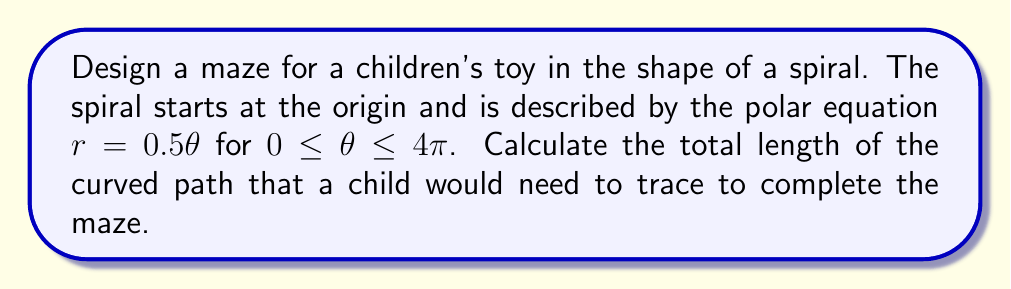Give your solution to this math problem. To find the length of the curved path in polar form, we need to use the arc length formula for polar curves:

$$L = \int_a^b \sqrt{r^2 + \left(\frac{dr}{d\theta}\right)^2} d\theta$$

Where $r$ is the radius, and $\theta$ is the angle in radians.

Step 1: Identify the given information
- Polar equation: $r = 0.5\theta$
- Limits: $0 \leq \theta \leq 4\pi$

Step 2: Find $\frac{dr}{d\theta}$
$$\frac{dr}{d\theta} = 0.5$$

Step 3: Substitute into the arc length formula
$$L = \int_0^{4\pi} \sqrt{(0.5\theta)^2 + (0.5)^2} d\theta$$

Step 4: Simplify the expression under the square root
$$L = \int_0^{4\pi} \sqrt{0.25\theta^2 + 0.25} d\theta$$
$$L = 0.5 \int_0^{4\pi} \sqrt{\theta^2 + 1} d\theta$$

Step 5: This integral can be solved using the substitution $\theta = \sinh u$. After substitution and simplification, we get:

$$L = 0.5 \left[ \theta\sqrt{\theta^2 + 1} + \ln(\theta + \sqrt{\theta^2 + 1}) \right]_0^{4\pi}$$

Step 6: Evaluate the expression at the limits
$$L = 0.5 \left[ (4\pi\sqrt{16\pi^2 + 1} + \ln(4\pi + \sqrt{16\pi^2 + 1})) - (0 + \ln(1)) \right]$$

Step 7: Calculate the final result (rounded to two decimal places)
$$L \approx 25.13$$
Answer: The total length of the curved path in the spiral maze is approximately 25.13 units. 